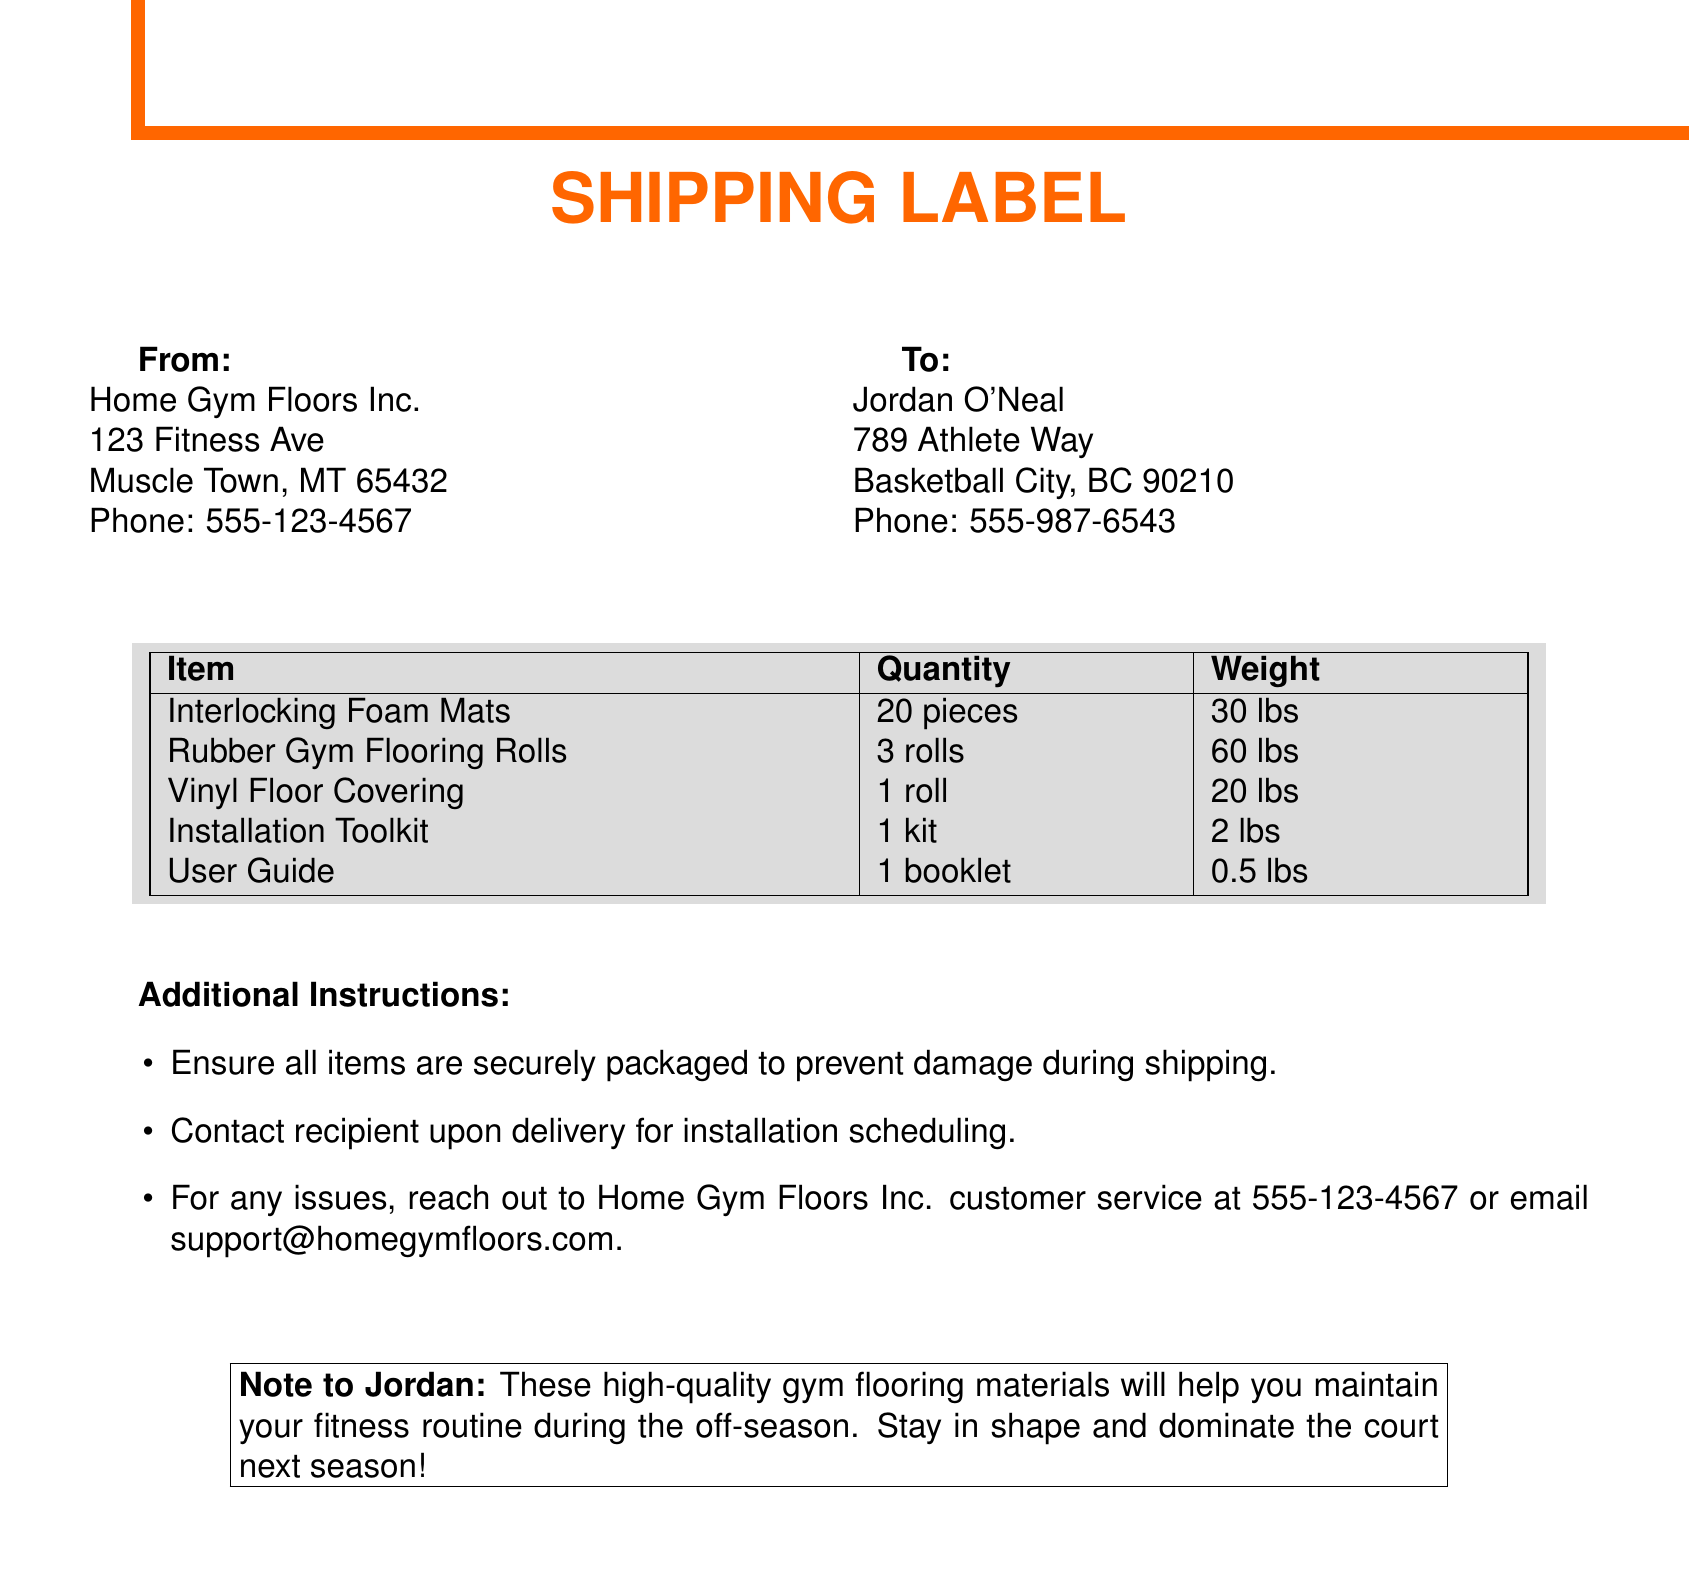What is the name of the sender? The sender's name is located in the "From" section of the document.
Answer: Home Gym Floors Inc What is the recipient's address? The recipient's address is indicated in the "To" section of the document.
Answer: 789 Athlete Way, Basketball City, BC 90210 How many pieces of interlocking foam mats are included? The quantity of interlocking foam mats is listed in the table of items.
Answer: 20 pieces What is the total weight of the rubber gym flooring rolls? The weight of rubber gym flooring rolls is specified in the item table.
Answer: 60 lbs What is the phone number of Home Gym Floors Inc.? The phone number can be found under the "From" section.
Answer: 555-123-4567 What is the purpose of the installation toolkit? The installation toolkit is intended for setting up the gym flooring materials.
Answer: Installation What additional step should be taken upon delivery? An additional instruction highlights a specific action to take after delivery.
Answer: Contact recipient What does the note to Jordan emphasize? The note provides motivation related to the use of gym flooring.
Answer: Maintain fitness routine How are the items supposed to be packaged? The instructions specify the packaging conditions required during shipping.
Answer: Securely packaged 